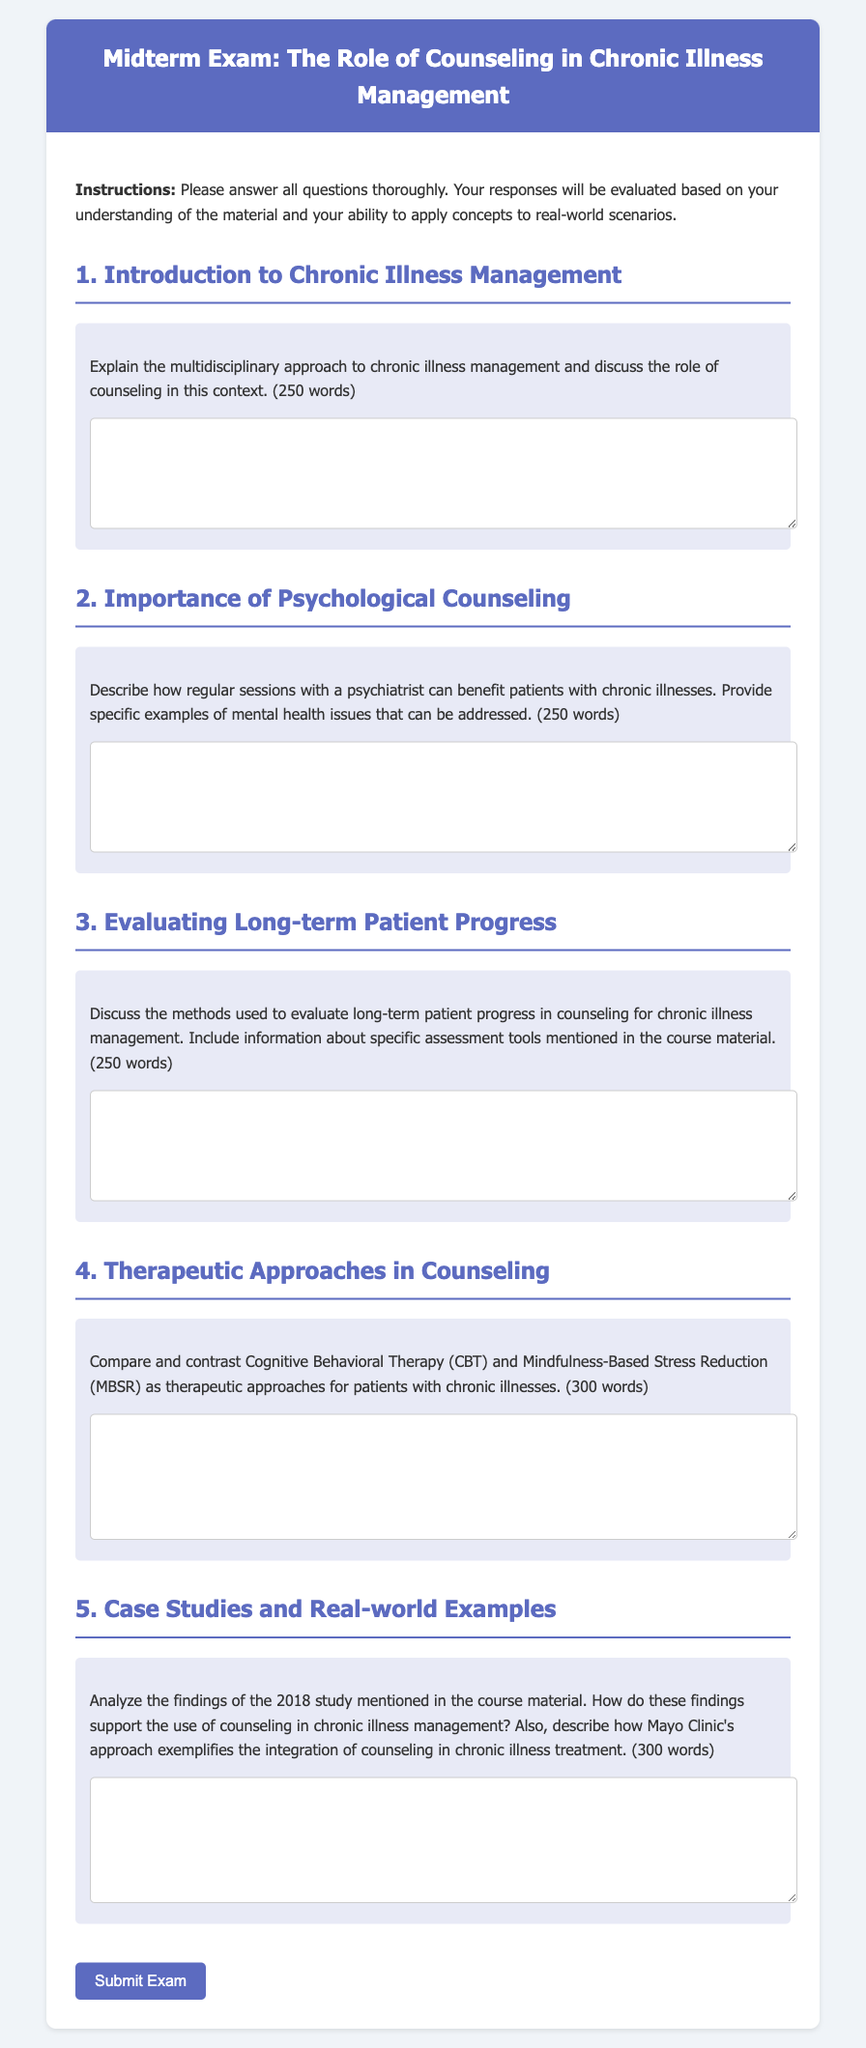What is the title of the exam? The title of the exam is given in the header of the document.
Answer: Midterm Exam: The Role of Counseling in Chronic Illness Management What is the maximum word count for the first question? The first question specifies a word limit for the answer, which can be found in the text.
Answer: 250 words How many therapeutic approaches are compared in the fourth question? The fourth question explicitly states the two therapeutic approaches to be compared.
Answer: 2 What type of counseling is discussed in the second question? The second question specifies the type of mental health professional whose sessions are beneficial for patients.
Answer: psychiatrist Which institution's approach is mentioned in relation to chronic illness treatment? The course material references a specific institution in the context of the study findings.
Answer: Mayo Clinic What is the color scheme of the exam header? The styling of the exam header can be inferred from the HTML code.
Answer: Blue and white How many questions are included in the exam? The number of questions can be tallied based on the sections displayed in the content.
Answer: 5 What format should responses be in? The instructions in the document specify how responses should be structured.
Answer: Thorough written answers 